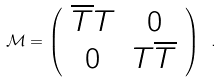Convert formula to latex. <formula><loc_0><loc_0><loc_500><loc_500>\mathcal { M } = \left ( \begin{array} { c c } \overline { T } T & 0 \\ 0 & T \overline { T } \\ \end{array} \right ) \ .</formula> 